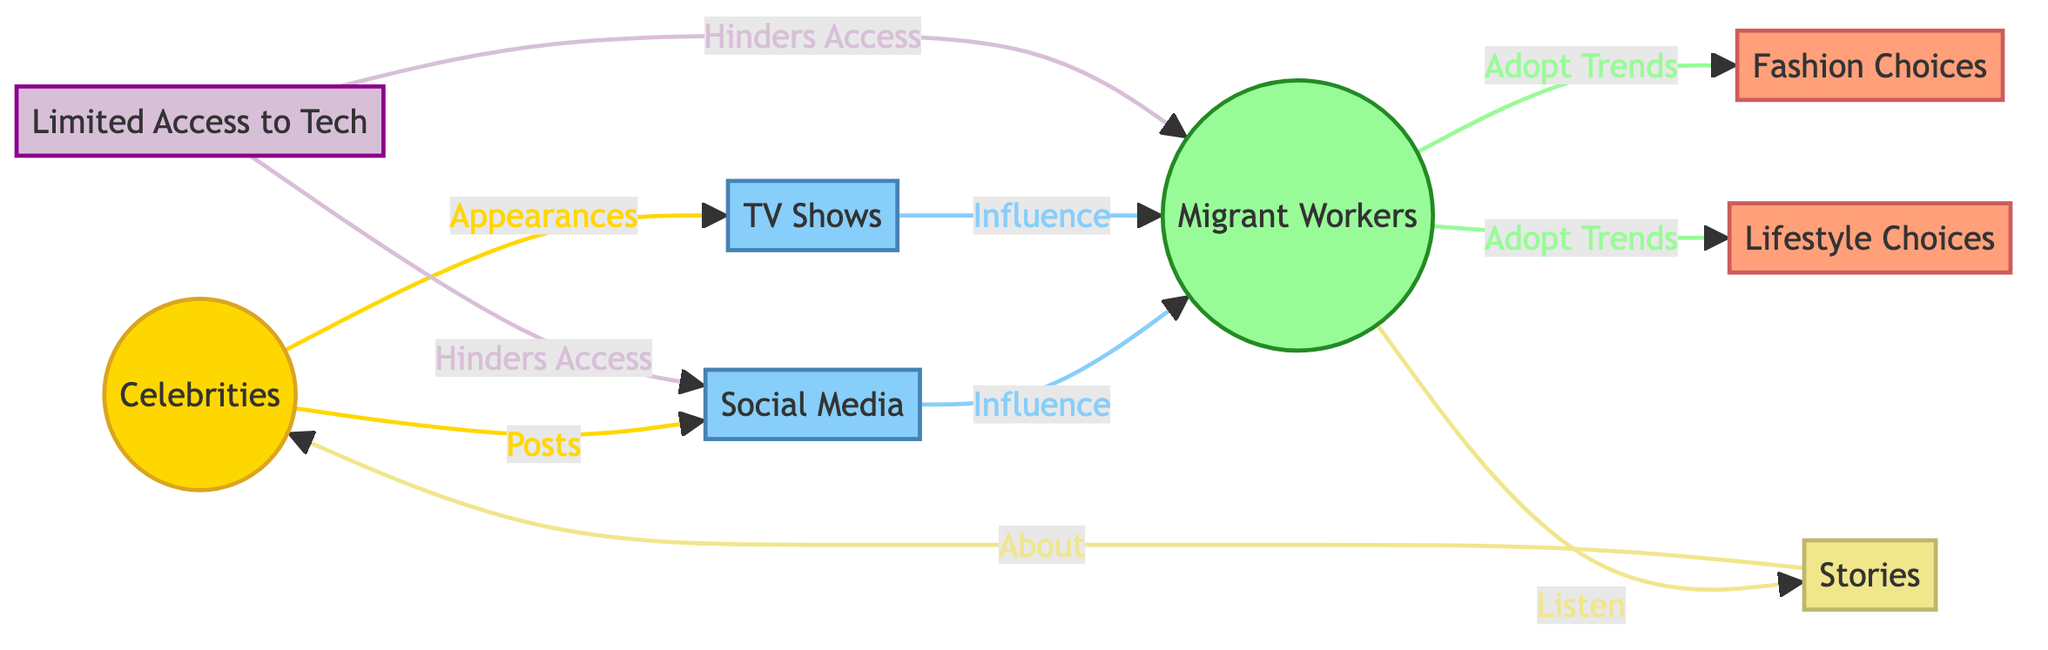What are the main influences on migrant workers in the diagram? The diagram shows two main influences on migrant workers, which are social media and TV shows. They connect directly from the celebrities node, indicating that both platforms transmit influence to migrant workers.
Answer: Social media and TV shows How many nodes are there in total in the diagram? Counting all unique entities in the diagram, there are 8 nodes: Celebrities, Social Media, TV Shows, Migrant Workers, Fashion Choices, Lifestyle Choices, Limited Access to Tech, and Stories.
Answer: 8 What do migrant workers adopt trends in? The diagram indicates that migrant workers adopt trends in both fashion choices and lifestyle choices as a result of influence from celebrities through social media and TV shows.
Answer: Fashion choices and lifestyle choices Which element directly denotes the challenge for migrant workers regarding technology? The node "Limited Access to Tech" indicates the challenge faced by migrant workers in accessing social media and being influenced by celebrities. This node has arrows pointing to both migrant workers and social media.
Answer: Limited Access to Tech What role do stories play in the influence of celebrities? In the diagram, stories are shown as a secondary influence that migrant workers listen to, specifically about celebrities. This indicates that stories contribute to reinforcing the celebrities' influence on migrant workers' choices.
Answer: About celebrities In how many ways do celebrities influence migrant workers according to the diagram? The diagram demonstrates that celebrities influence migrant workers in two distinct ways: through posts on social media and appearances on TV shows. Both pathways are represented in the flow from the celebrities node to the migrant workers node.
Answer: 2 Ways 